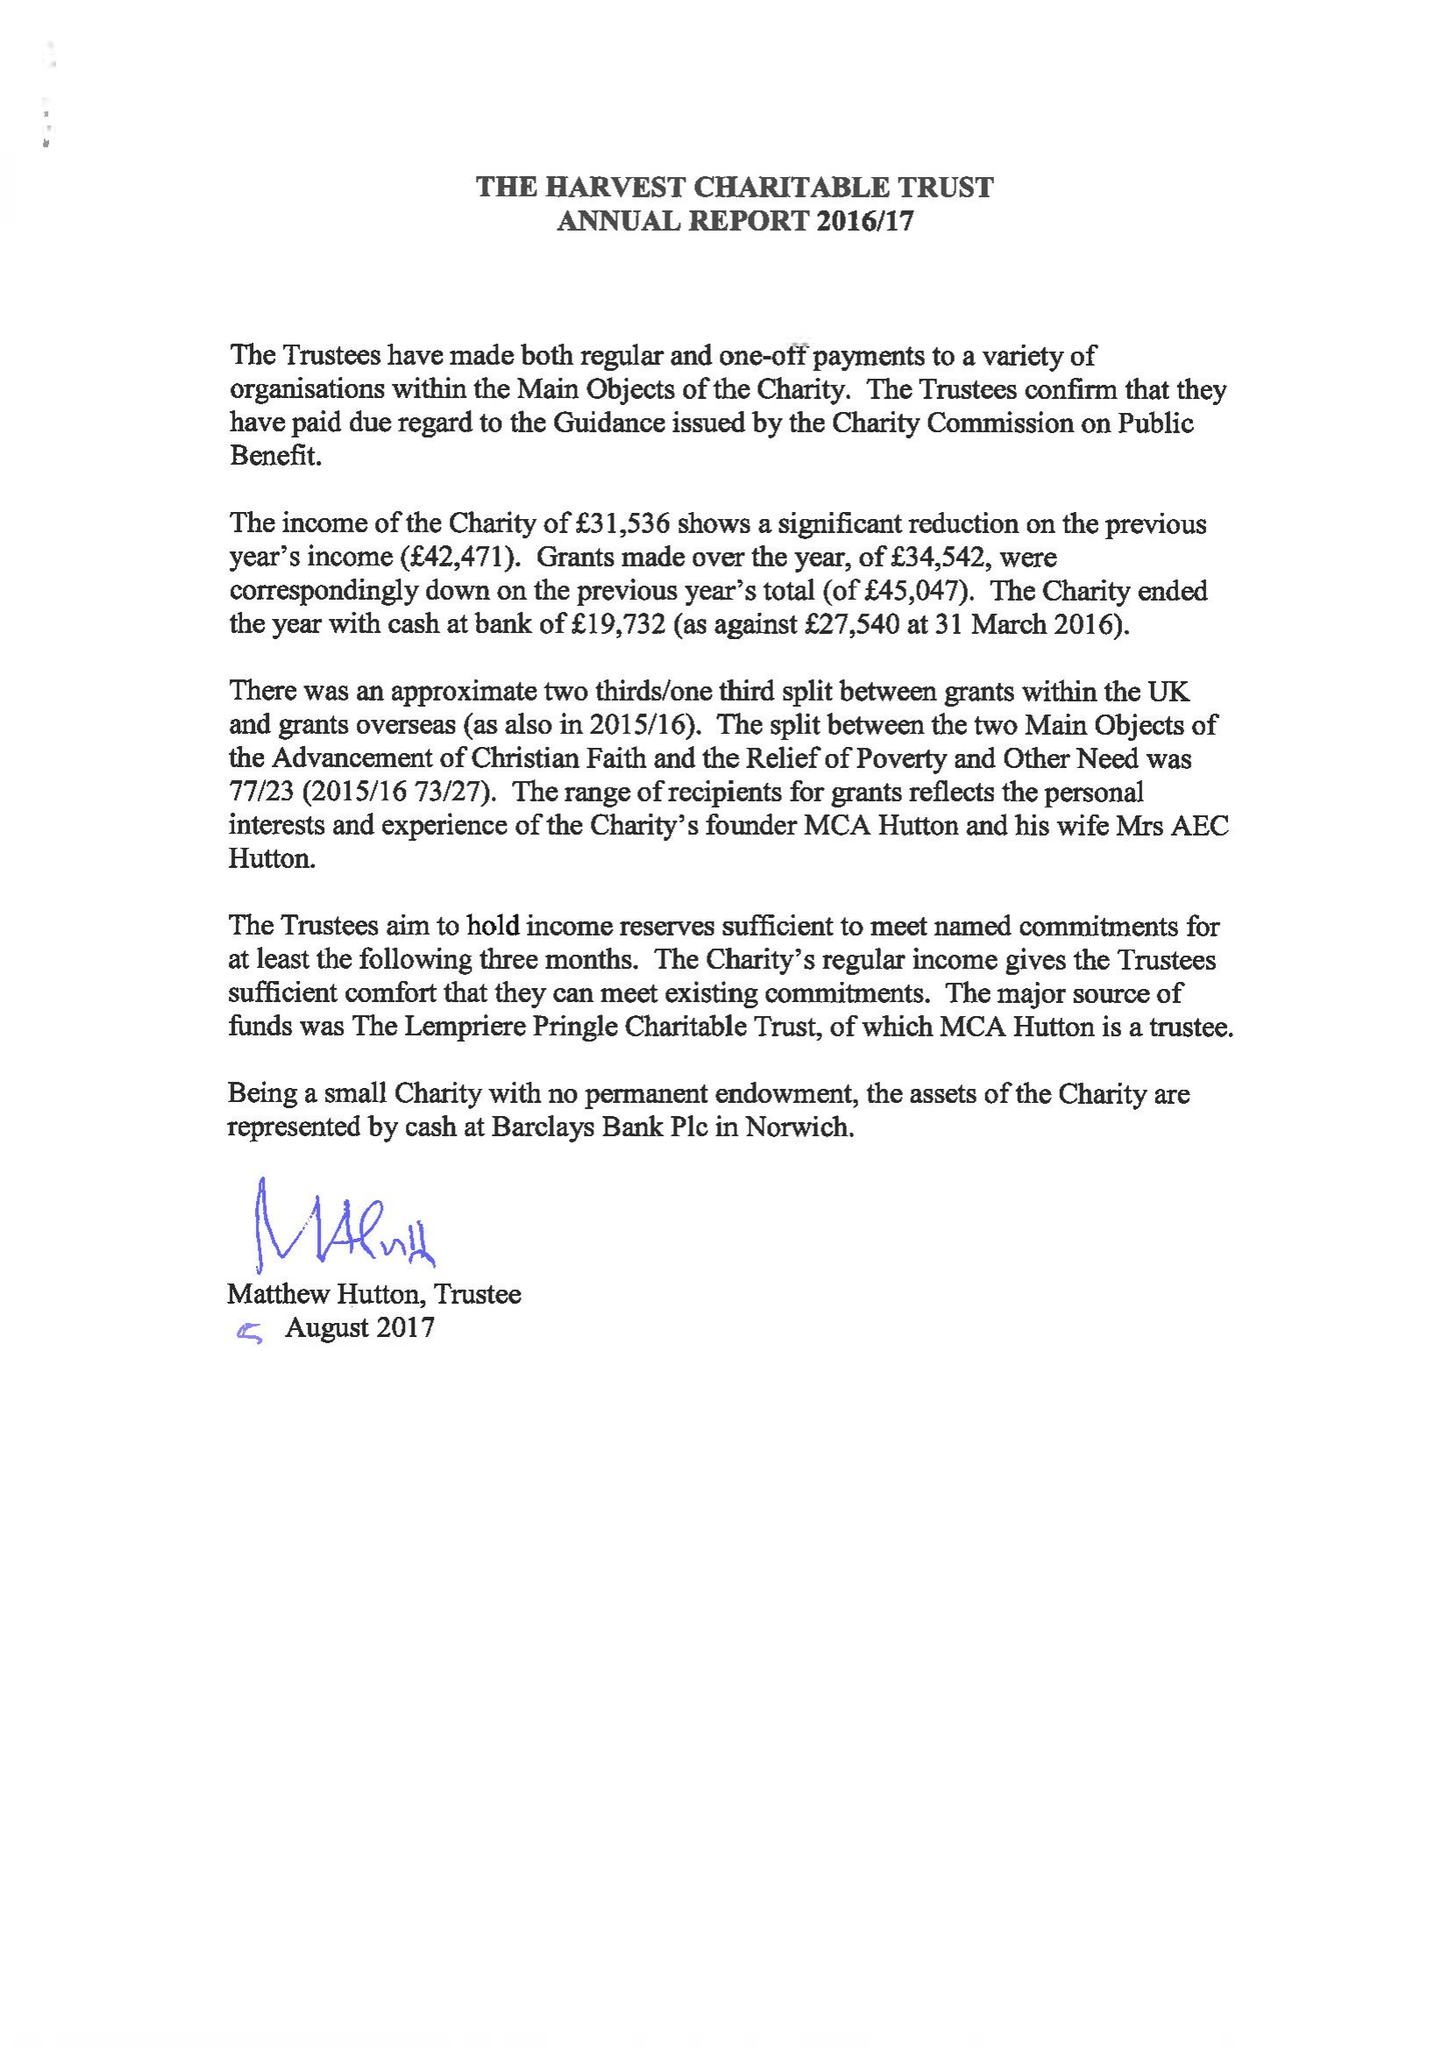What is the value for the charity_name?
Answer the question using a single word or phrase. The Harvest Charitable Trust 